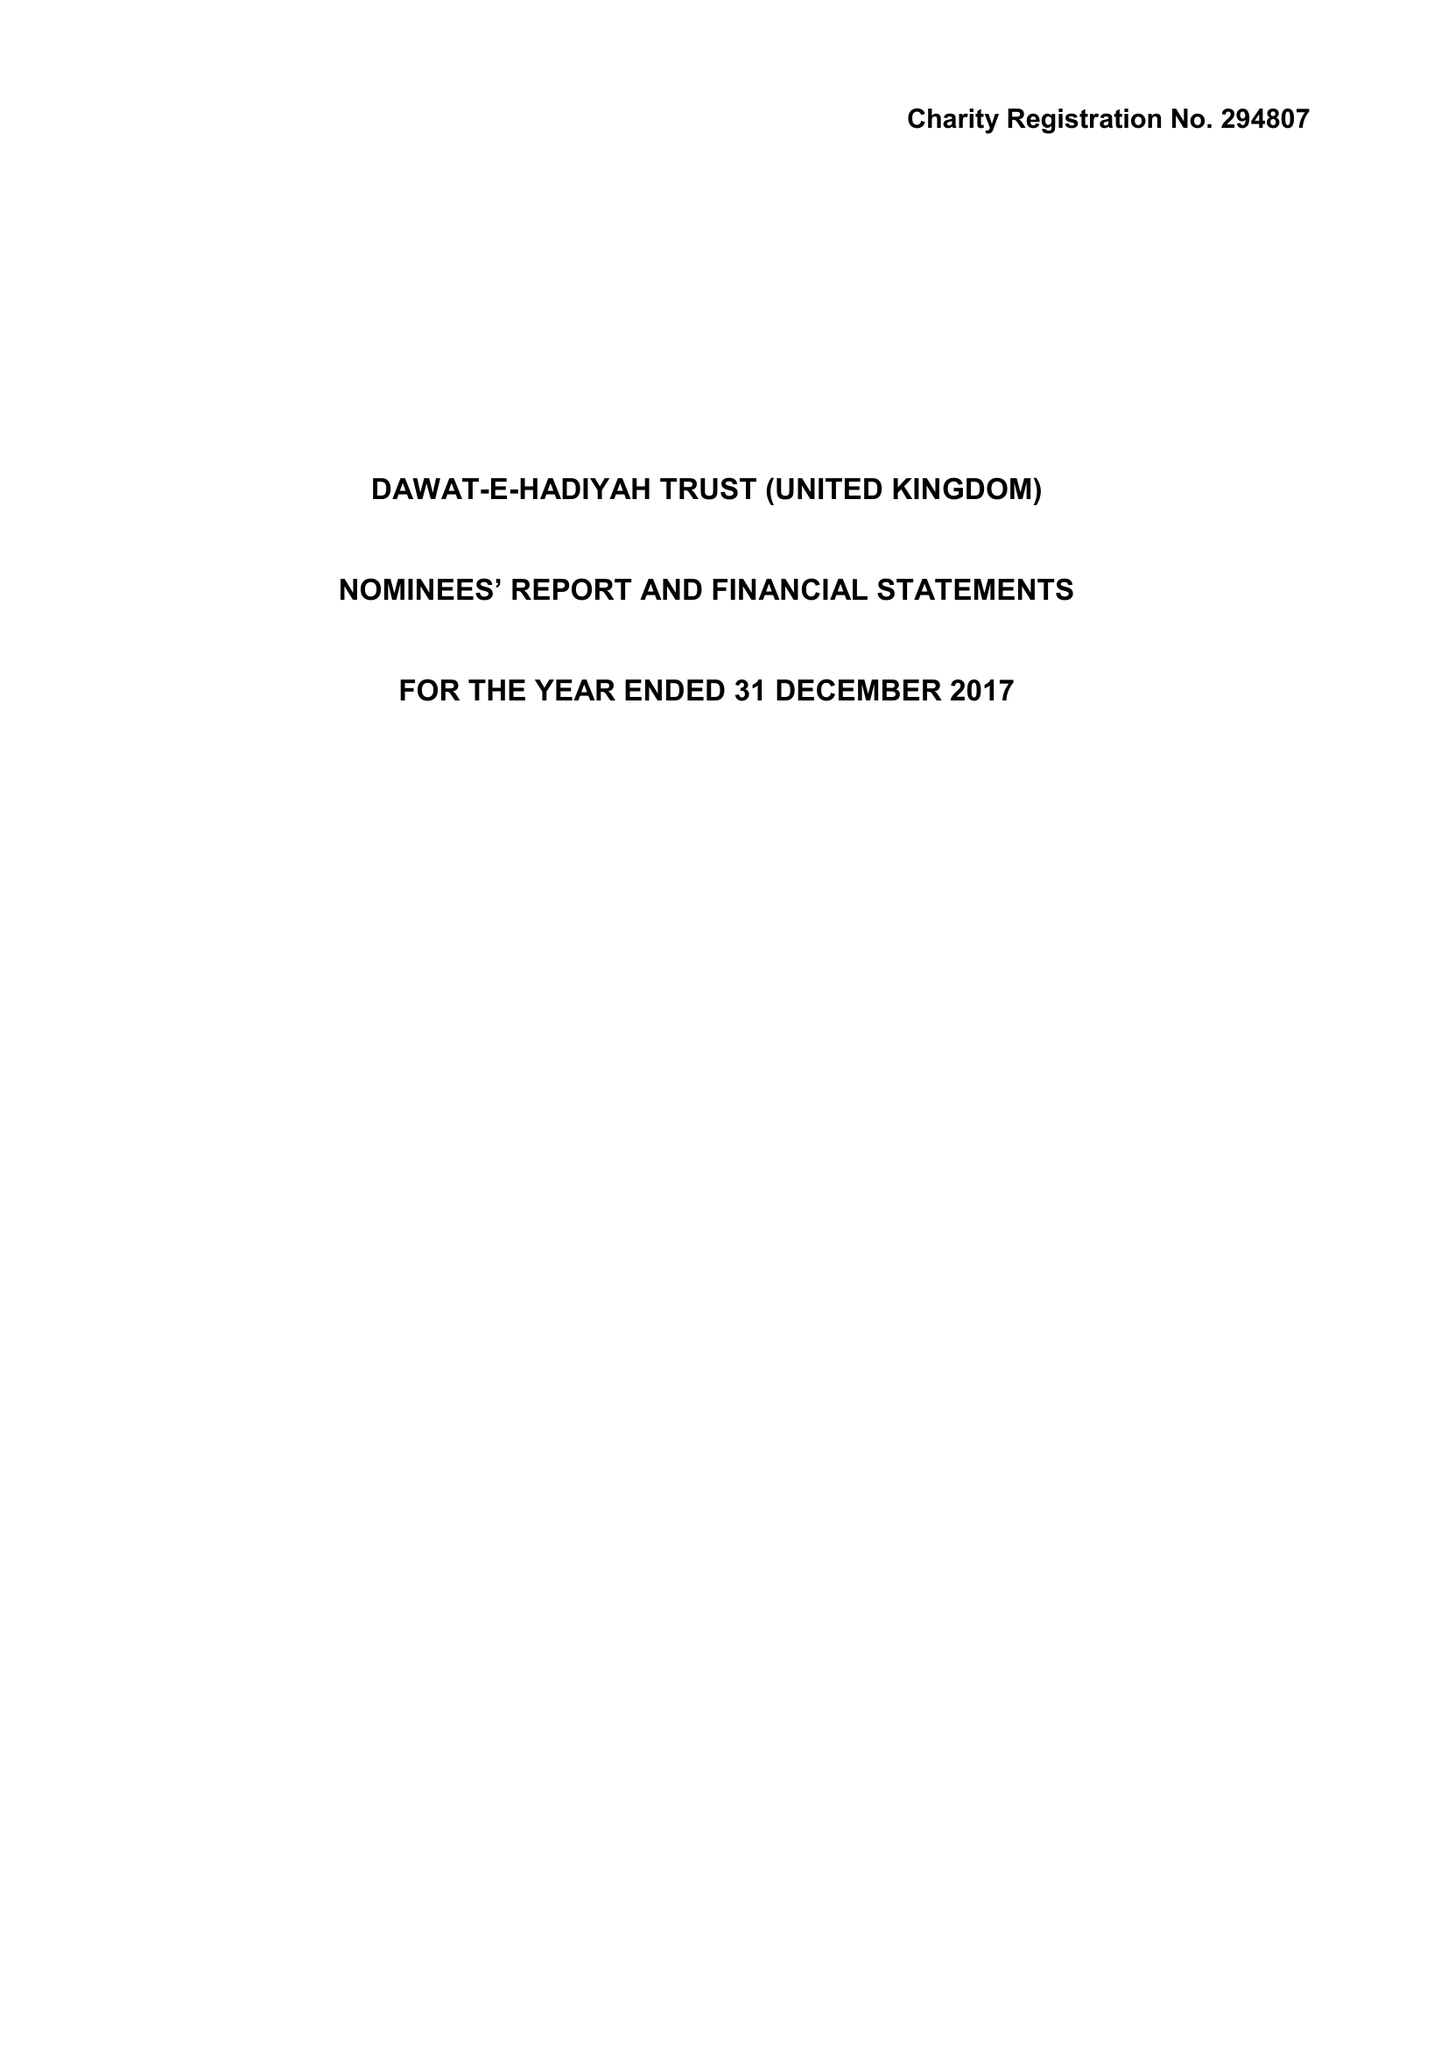What is the value for the address__post_town?
Answer the question using a single word or phrase. GREENFORD 